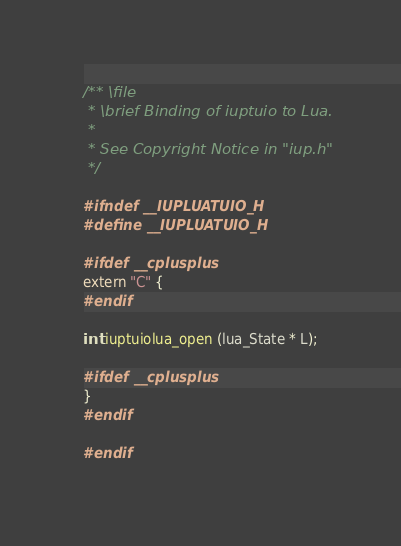Convert code to text. <code><loc_0><loc_0><loc_500><loc_500><_C_>/** \file
 * \brief Binding of iuptuio to Lua.
 *
 * See Copyright Notice in "iup.h"
 */
 
#ifndef __IUPLUATUIO_H 
#define __IUPLUATUIO_H

#ifdef __cplusplus
extern "C" {
#endif

int iuptuiolua_open (lua_State * L);

#ifdef __cplusplus
}
#endif

#endif
</code> 